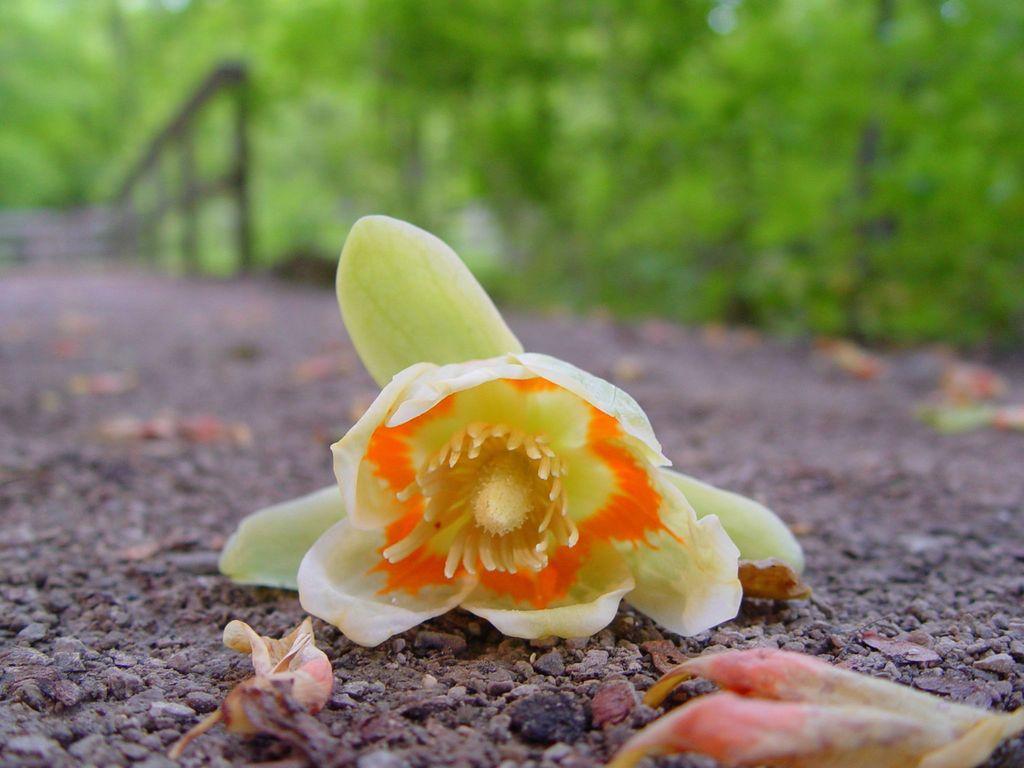Describe this image in one or two sentences. At the bottom of the picture, we see small stones and the dry flowers. In the middle, we see a flower in yellow and orange color. On the left side, we see a wall and the railing. There are trees in the background. This picture is blurred in the background. 